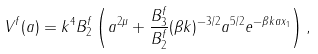<formula> <loc_0><loc_0><loc_500><loc_500>V ^ { f } ( a ) = k ^ { 4 } B _ { 2 } ^ { f } \left ( a ^ { 2 \mu } + \frac { B _ { 3 } ^ { f } } { B _ { 2 } ^ { f } } ( \beta k ) ^ { - 3 / 2 } a ^ { 5 / 2 } e ^ { - \beta k a x _ { 1 } } \right ) ,</formula> 